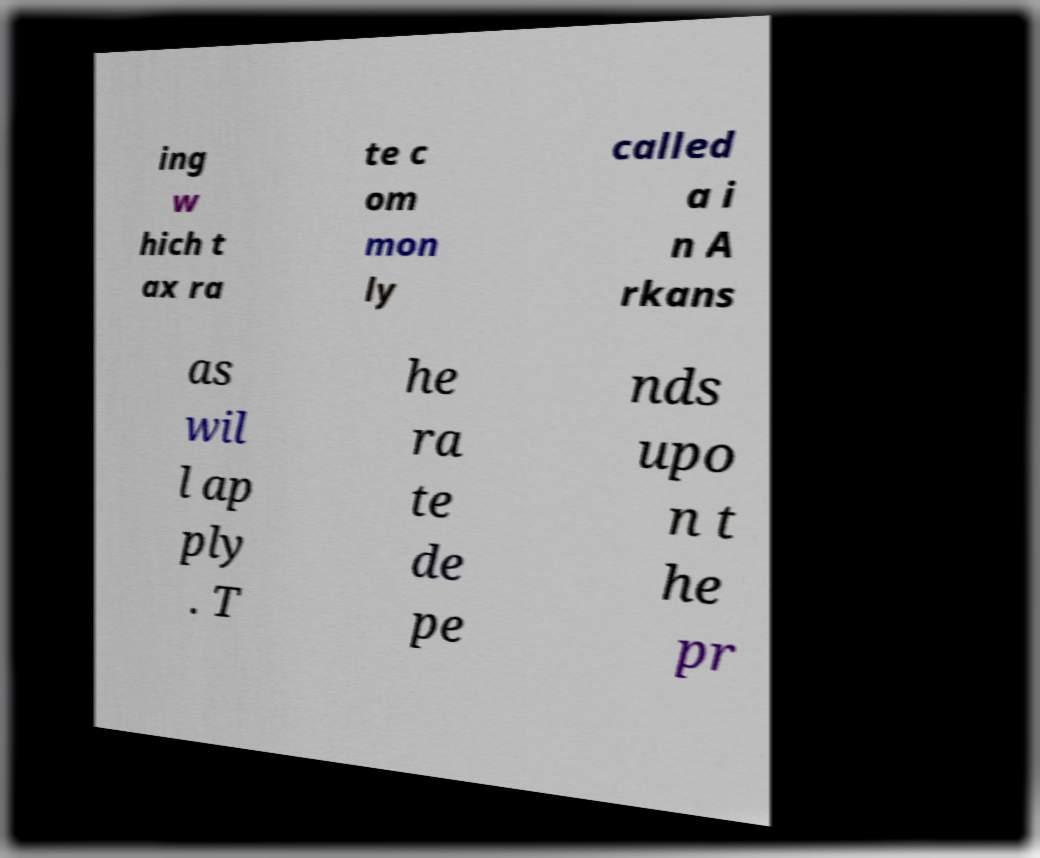There's text embedded in this image that I need extracted. Can you transcribe it verbatim? ing w hich t ax ra te c om mon ly called a i n A rkans as wil l ap ply . T he ra te de pe nds upo n t he pr 